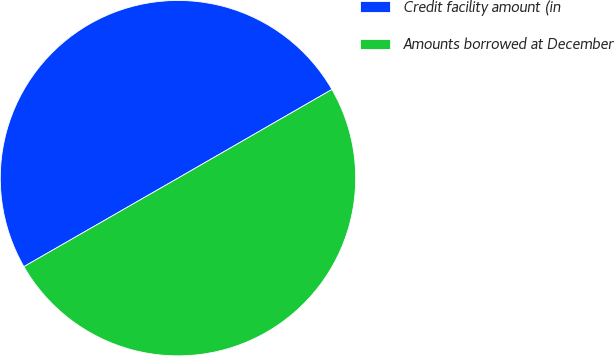<chart> <loc_0><loc_0><loc_500><loc_500><pie_chart><fcel>Credit facility amount (in<fcel>Amounts borrowed at December<nl><fcel>49.98%<fcel>50.02%<nl></chart> 